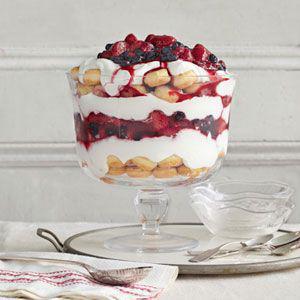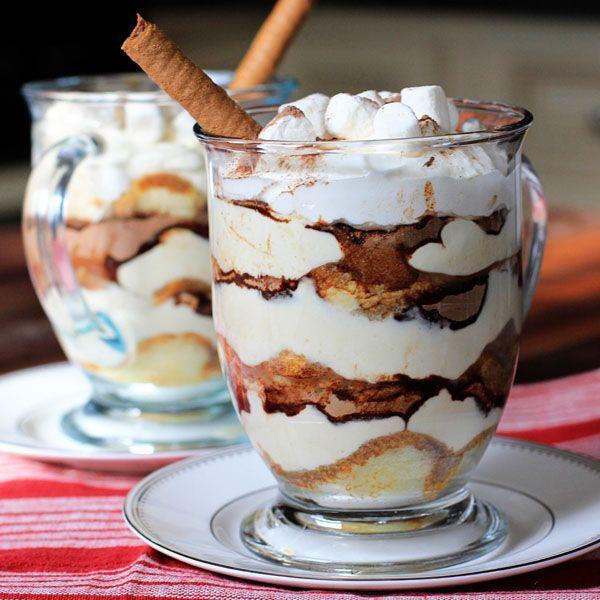The first image is the image on the left, the second image is the image on the right. Examine the images to the left and right. Is the description "An image shows a dessert topped with red berries and served in a stout footed glass." accurate? Answer yes or no. Yes. The first image is the image on the left, the second image is the image on the right. Evaluate the accuracy of this statement regarding the images: "There is exactly one dessert in an open jar in one of the images". Is it true? Answer yes or no. No. 